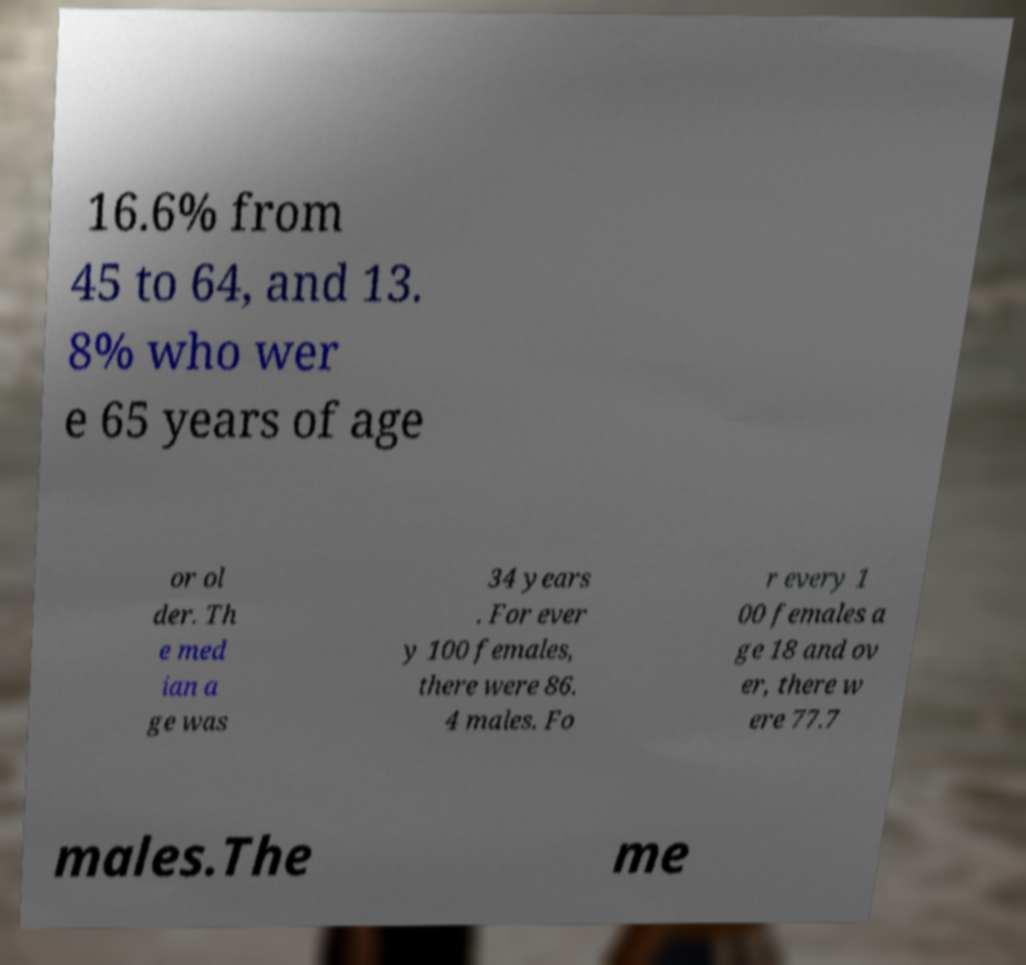I need the written content from this picture converted into text. Can you do that? 16.6% from 45 to 64, and 13. 8% who wer e 65 years of age or ol der. Th e med ian a ge was 34 years . For ever y 100 females, there were 86. 4 males. Fo r every 1 00 females a ge 18 and ov er, there w ere 77.7 males.The me 